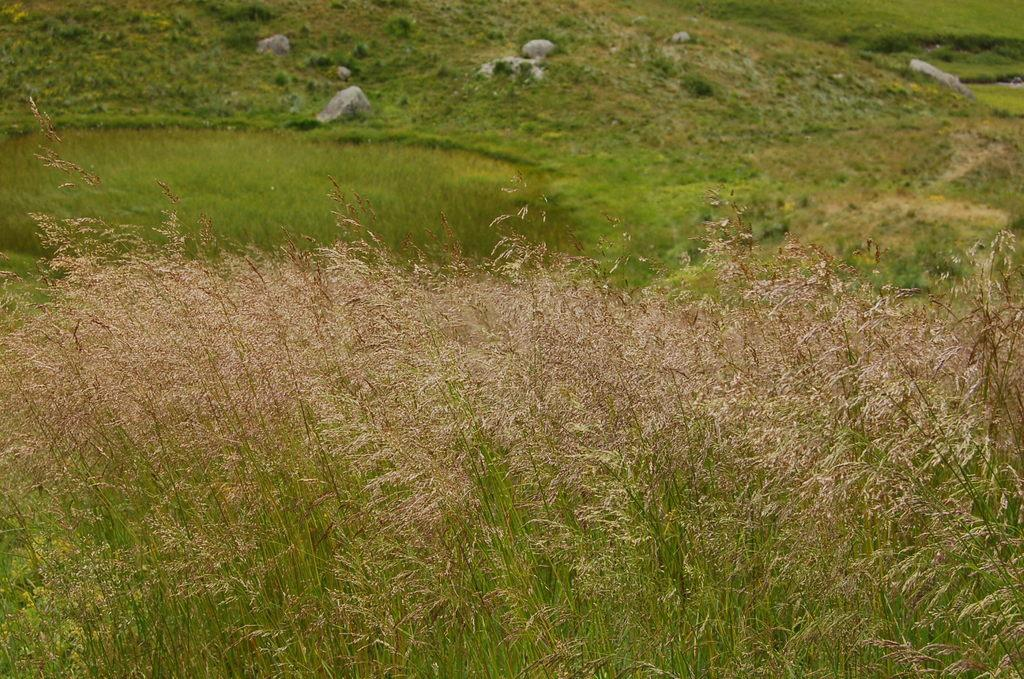What type of living organisms can be seen in the image? Plants can be seen in the image. What type of material is present on the ground in the image? There are stones on the ground in the image. What type of vegetation is visible in the background of the image? Grass is visible in the background of the image. What type of lock is used to secure the cellar in the image? There is no lock or cellar present in the image. 